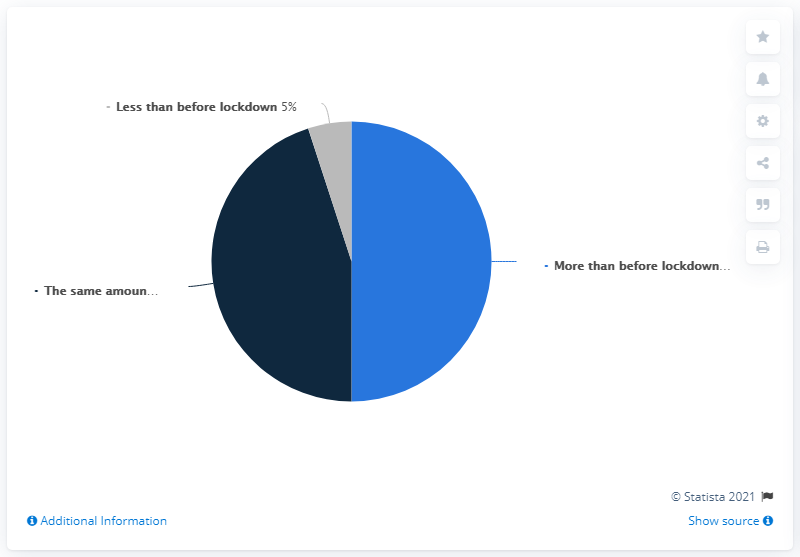Mention a couple of crucial points in this snapshot. I believe that the opinion that has the least value is less than before the lockdown. The least to the other two are different. 